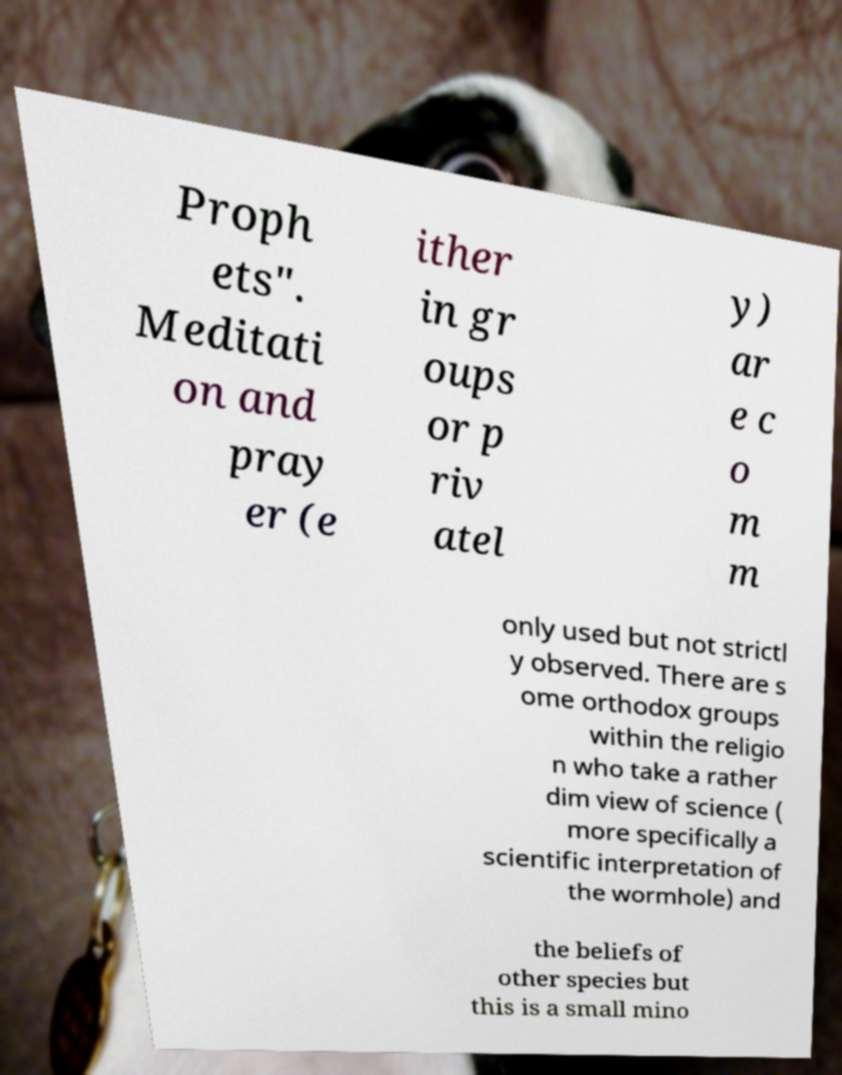I need the written content from this picture converted into text. Can you do that? Proph ets". Meditati on and pray er (e ither in gr oups or p riv atel y) ar e c o m m only used but not strictl y observed. There are s ome orthodox groups within the religio n who take a rather dim view of science ( more specifically a scientific interpretation of the wormhole) and the beliefs of other species but this is a small mino 